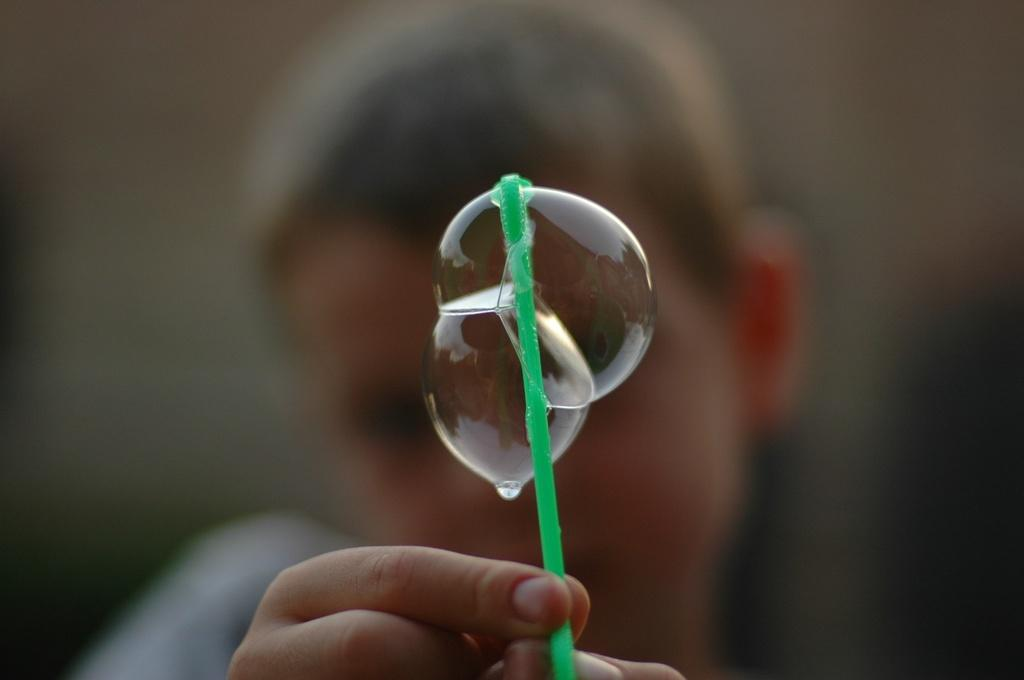Who is the main subject in the image? There is a boy in the image. What is the boy holding in the image? The boy is holding a straw in the image. What can be seen in the center of the image? There are bubbles in the center of the image. What type of border is present around the image? There is no information about a border around the image, as the provided facts only mention the boy, the straw, and the bubbles. 